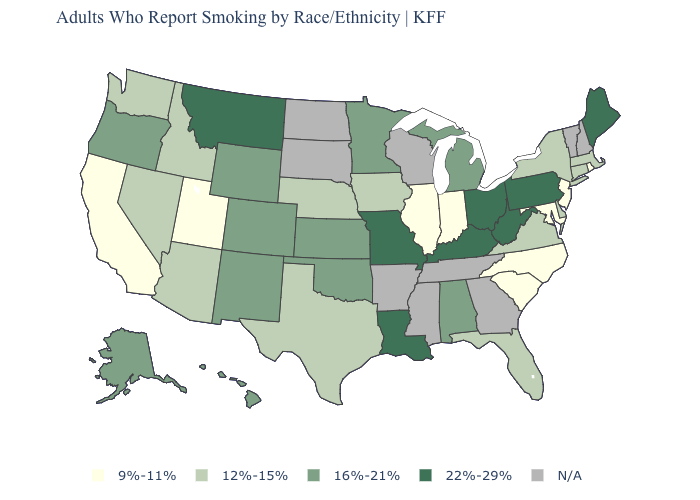Name the states that have a value in the range 22%-29%?
Answer briefly. Kentucky, Louisiana, Maine, Missouri, Montana, Ohio, Pennsylvania, West Virginia. What is the value of Arizona?
Keep it brief. 12%-15%. What is the value of Illinois?
Quick response, please. 9%-11%. Among the states that border Pennsylvania , which have the lowest value?
Keep it brief. Maryland, New Jersey. What is the value of Arizona?
Answer briefly. 12%-15%. Which states have the highest value in the USA?
Answer briefly. Kentucky, Louisiana, Maine, Missouri, Montana, Ohio, Pennsylvania, West Virginia. Name the states that have a value in the range 22%-29%?
Write a very short answer. Kentucky, Louisiana, Maine, Missouri, Montana, Ohio, Pennsylvania, West Virginia. Name the states that have a value in the range N/A?
Answer briefly. Arkansas, Georgia, Mississippi, New Hampshire, North Dakota, South Dakota, Tennessee, Vermont, Wisconsin. Which states have the highest value in the USA?
Write a very short answer. Kentucky, Louisiana, Maine, Missouri, Montana, Ohio, Pennsylvania, West Virginia. Name the states that have a value in the range 16%-21%?
Be succinct. Alabama, Alaska, Colorado, Hawaii, Kansas, Michigan, Minnesota, New Mexico, Oklahoma, Oregon, Wyoming. Among the states that border Minnesota , which have the highest value?
Concise answer only. Iowa. What is the value of Connecticut?
Concise answer only. 12%-15%. Does the first symbol in the legend represent the smallest category?
Write a very short answer. Yes. Is the legend a continuous bar?
Quick response, please. No. 